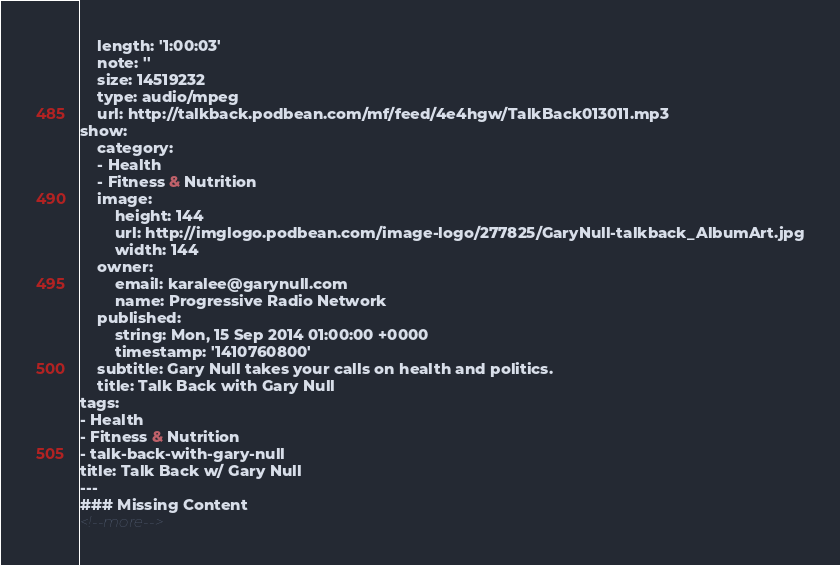Convert code to text. <code><loc_0><loc_0><loc_500><loc_500><_HTML_>    length: '1:00:03'
    note: ''
    size: 14519232
    type: audio/mpeg
    url: http://talkback.podbean.com/mf/feed/4e4hgw/TalkBack013011.mp3
show:
    category:
    - Health
    - Fitness & Nutrition
    image:
        height: 144
        url: http://imglogo.podbean.com/image-logo/277825/GaryNull-talkback_AlbumArt.jpg
        width: 144
    owner:
        email: karalee@garynull.com
        name: Progressive Radio Network
    published:
        string: Mon, 15 Sep 2014 01:00:00 +0000
        timestamp: '1410760800'
    subtitle: Gary Null takes your calls on health and politics.
    title: Talk Back with Gary Null
tags:
- Health
- Fitness & Nutrition
- talk-back-with-gary-null
title: Talk Back w/ Gary Null
---
### Missing Content
<!--more-->
</code> 